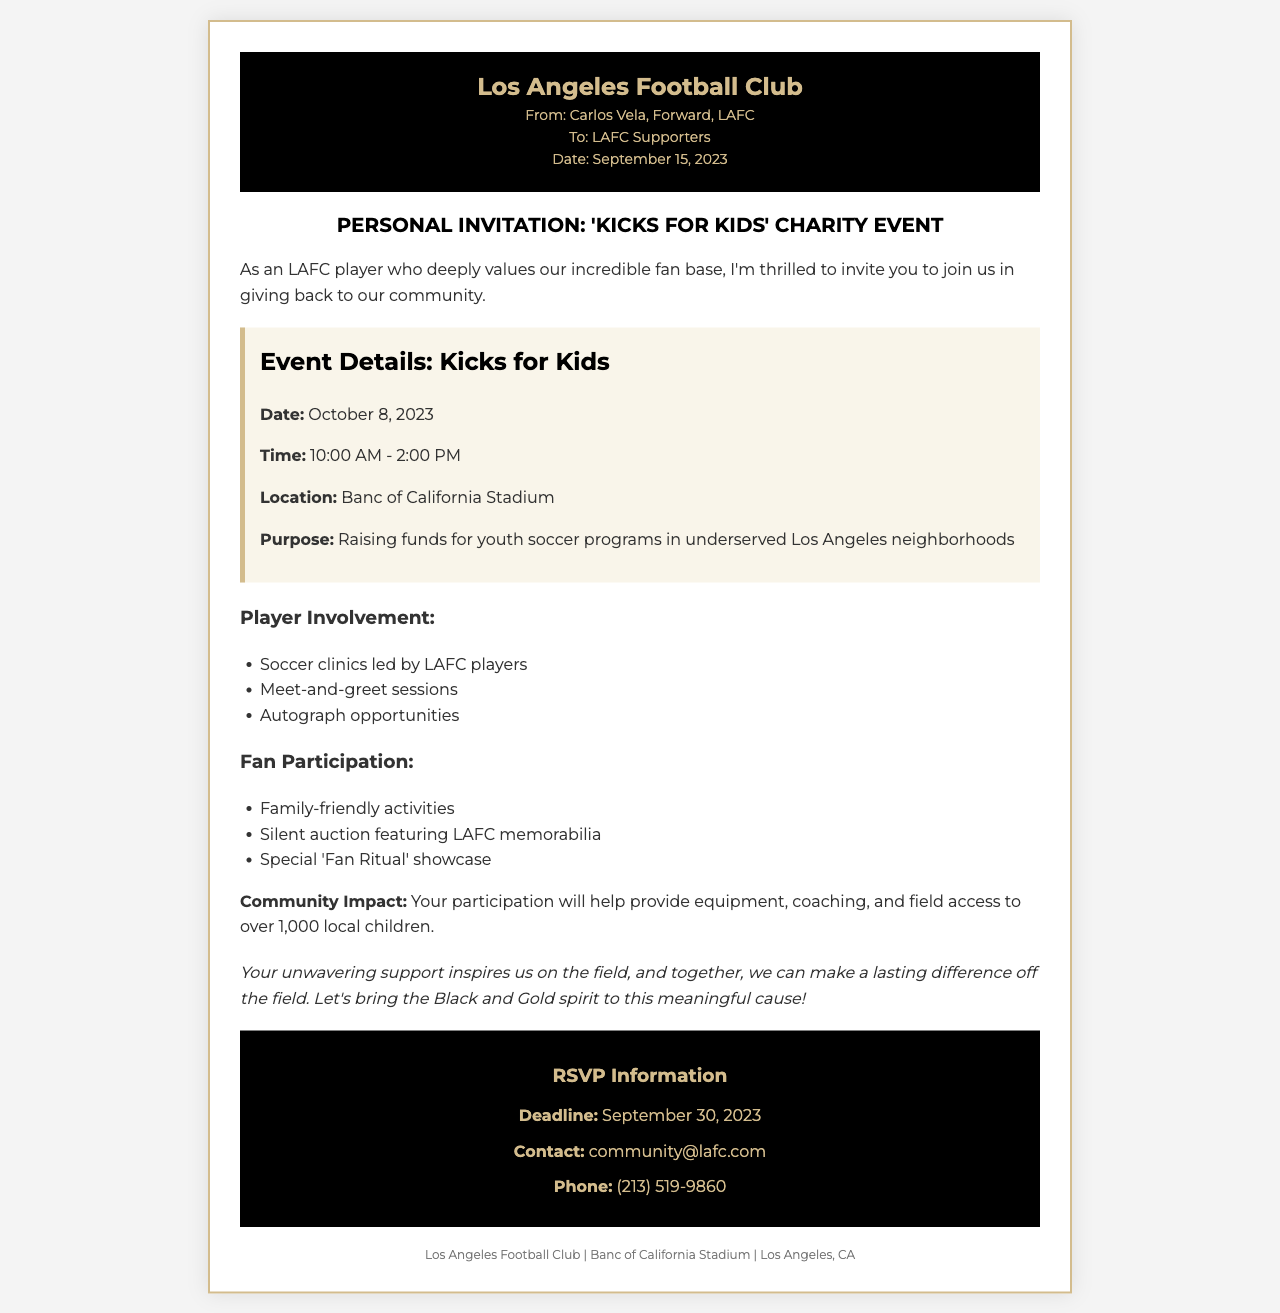What is the name of the charity event? The name of the charity event is mentioned in the subject line of the document as "Kicks for Kids."
Answer: Kicks for Kids What is the date of the charity event? The date of the charity event is provided under the event details section of the document.
Answer: October 8, 2023 Where is the event taking place? The location of the event is specified in the event details section as the venue for the event.
Answer: Banc of California Stadium What time does the event start? The starting time of the event is listed in the event details section of the document.
Answer: 10:00 AM What is the purpose of the event? The purpose of the event is mentioned clearly in the event details section.
Answer: Raising funds for youth soccer programs in underserved Los Angeles neighborhoods How many local children will benefit from the community impact? The number of local children benefiting from the event is indicated in the community impact section of the document.
Answer: Over 1,000 What type of activities will be included for the fans? The type of fan participation is outlined in the document under the fan participation section.
Answer: Family-friendly activities Who is the sender of the invitation? The sender of the invitation is mentioned in the header of the document with their position.
Answer: Carlos Vela What is the RSVP deadline? The RSVP deadline is specified in the RSVP section of the document.
Answer: September 30, 2023 